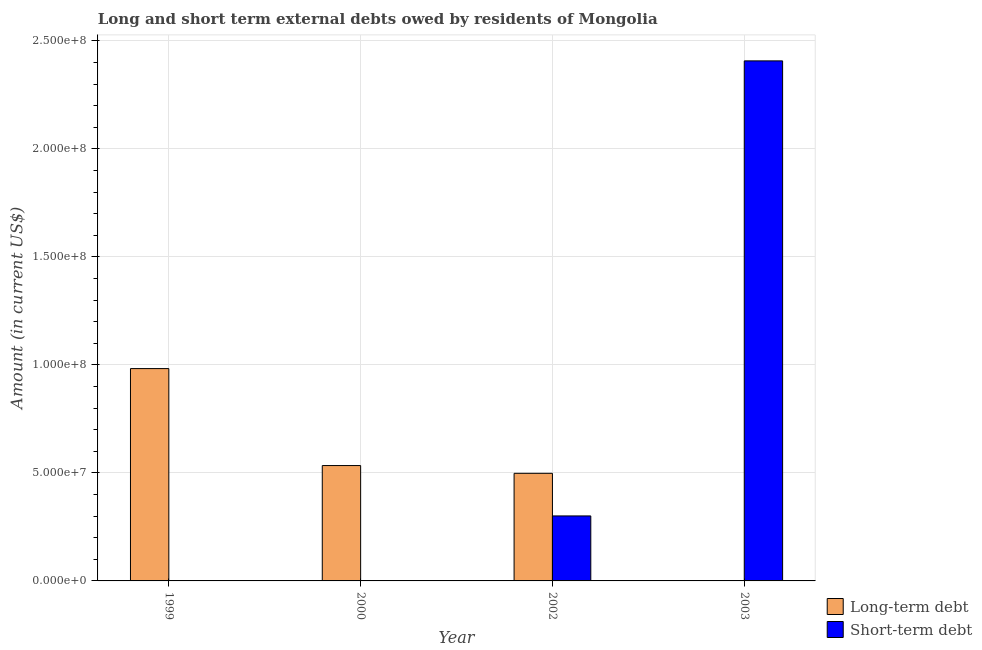Are the number of bars on each tick of the X-axis equal?
Your answer should be very brief. No. How many bars are there on the 4th tick from the left?
Make the answer very short. 1. What is the short-term debts owed by residents in 2003?
Your answer should be very brief. 2.41e+08. Across all years, what is the maximum short-term debts owed by residents?
Ensure brevity in your answer.  2.41e+08. What is the total long-term debts owed by residents in the graph?
Make the answer very short. 2.02e+08. What is the difference between the short-term debts owed by residents in 2002 and that in 2003?
Keep it short and to the point. -2.11e+08. What is the difference between the short-term debts owed by residents in 2003 and the long-term debts owed by residents in 1999?
Provide a succinct answer. 2.41e+08. What is the average long-term debts owed by residents per year?
Keep it short and to the point. 5.04e+07. In the year 2000, what is the difference between the long-term debts owed by residents and short-term debts owed by residents?
Your response must be concise. 0. In how many years, is the long-term debts owed by residents greater than 80000000 US$?
Provide a succinct answer. 1. What is the ratio of the long-term debts owed by residents in 1999 to that in 2000?
Provide a succinct answer. 1.84. Is the long-term debts owed by residents in 2000 less than that in 2002?
Your response must be concise. No. What is the difference between the highest and the second highest long-term debts owed by residents?
Give a very brief answer. 4.49e+07. What is the difference between the highest and the lowest long-term debts owed by residents?
Your answer should be very brief. 9.83e+07. Is the sum of the short-term debts owed by residents in 2002 and 2003 greater than the maximum long-term debts owed by residents across all years?
Your answer should be compact. Yes. How many years are there in the graph?
Ensure brevity in your answer.  4. What is the difference between two consecutive major ticks on the Y-axis?
Offer a terse response. 5.00e+07. Does the graph contain any zero values?
Your answer should be compact. Yes. What is the title of the graph?
Offer a terse response. Long and short term external debts owed by residents of Mongolia. What is the label or title of the Y-axis?
Keep it short and to the point. Amount (in current US$). What is the Amount (in current US$) in Long-term debt in 1999?
Your answer should be very brief. 9.83e+07. What is the Amount (in current US$) of Short-term debt in 1999?
Provide a short and direct response. 0. What is the Amount (in current US$) in Long-term debt in 2000?
Provide a short and direct response. 5.34e+07. What is the Amount (in current US$) in Short-term debt in 2000?
Provide a succinct answer. 0. What is the Amount (in current US$) of Long-term debt in 2002?
Your answer should be compact. 4.98e+07. What is the Amount (in current US$) of Short-term debt in 2002?
Offer a very short reply. 3.01e+07. What is the Amount (in current US$) in Long-term debt in 2003?
Ensure brevity in your answer.  0. What is the Amount (in current US$) in Short-term debt in 2003?
Offer a terse response. 2.41e+08. Across all years, what is the maximum Amount (in current US$) of Long-term debt?
Make the answer very short. 9.83e+07. Across all years, what is the maximum Amount (in current US$) in Short-term debt?
Make the answer very short. 2.41e+08. What is the total Amount (in current US$) in Long-term debt in the graph?
Your response must be concise. 2.02e+08. What is the total Amount (in current US$) in Short-term debt in the graph?
Give a very brief answer. 2.71e+08. What is the difference between the Amount (in current US$) in Long-term debt in 1999 and that in 2000?
Your answer should be compact. 4.49e+07. What is the difference between the Amount (in current US$) of Long-term debt in 1999 and that in 2002?
Your response must be concise. 4.85e+07. What is the difference between the Amount (in current US$) of Long-term debt in 2000 and that in 2002?
Ensure brevity in your answer.  3.60e+06. What is the difference between the Amount (in current US$) of Short-term debt in 2002 and that in 2003?
Offer a very short reply. -2.11e+08. What is the difference between the Amount (in current US$) of Long-term debt in 1999 and the Amount (in current US$) of Short-term debt in 2002?
Ensure brevity in your answer.  6.82e+07. What is the difference between the Amount (in current US$) of Long-term debt in 1999 and the Amount (in current US$) of Short-term debt in 2003?
Make the answer very short. -1.42e+08. What is the difference between the Amount (in current US$) in Long-term debt in 2000 and the Amount (in current US$) in Short-term debt in 2002?
Your response must be concise. 2.33e+07. What is the difference between the Amount (in current US$) in Long-term debt in 2000 and the Amount (in current US$) in Short-term debt in 2003?
Give a very brief answer. -1.87e+08. What is the difference between the Amount (in current US$) in Long-term debt in 2002 and the Amount (in current US$) in Short-term debt in 2003?
Your response must be concise. -1.91e+08. What is the average Amount (in current US$) of Long-term debt per year?
Give a very brief answer. 5.04e+07. What is the average Amount (in current US$) in Short-term debt per year?
Provide a succinct answer. 6.77e+07. In the year 2002, what is the difference between the Amount (in current US$) of Long-term debt and Amount (in current US$) of Short-term debt?
Give a very brief answer. 1.97e+07. What is the ratio of the Amount (in current US$) of Long-term debt in 1999 to that in 2000?
Your response must be concise. 1.84. What is the ratio of the Amount (in current US$) in Long-term debt in 1999 to that in 2002?
Provide a short and direct response. 1.97. What is the ratio of the Amount (in current US$) of Long-term debt in 2000 to that in 2002?
Give a very brief answer. 1.07. What is the ratio of the Amount (in current US$) in Short-term debt in 2002 to that in 2003?
Provide a succinct answer. 0.12. What is the difference between the highest and the second highest Amount (in current US$) of Long-term debt?
Keep it short and to the point. 4.49e+07. What is the difference between the highest and the lowest Amount (in current US$) of Long-term debt?
Make the answer very short. 9.83e+07. What is the difference between the highest and the lowest Amount (in current US$) in Short-term debt?
Keep it short and to the point. 2.41e+08. 